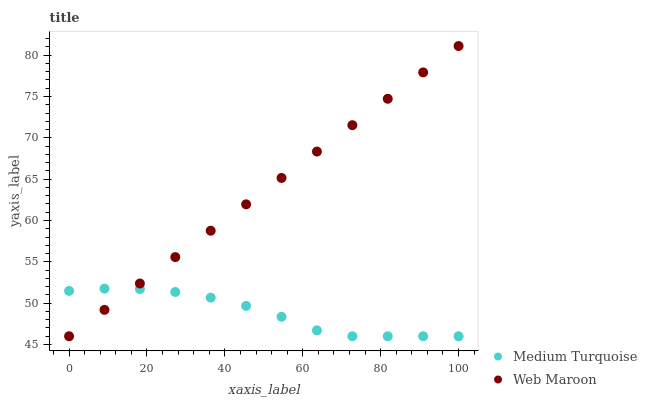Does Medium Turquoise have the minimum area under the curve?
Answer yes or no. Yes. Does Web Maroon have the maximum area under the curve?
Answer yes or no. Yes. Does Medium Turquoise have the maximum area under the curve?
Answer yes or no. No. Is Web Maroon the smoothest?
Answer yes or no. Yes. Is Medium Turquoise the roughest?
Answer yes or no. Yes. Is Medium Turquoise the smoothest?
Answer yes or no. No. Does Web Maroon have the lowest value?
Answer yes or no. Yes. Does Web Maroon have the highest value?
Answer yes or no. Yes. Does Medium Turquoise have the highest value?
Answer yes or no. No. Does Medium Turquoise intersect Web Maroon?
Answer yes or no. Yes. Is Medium Turquoise less than Web Maroon?
Answer yes or no. No. Is Medium Turquoise greater than Web Maroon?
Answer yes or no. No. 